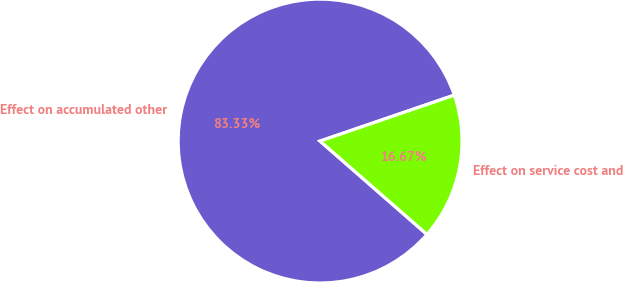Convert chart. <chart><loc_0><loc_0><loc_500><loc_500><pie_chart><fcel>Effect on accumulated other<fcel>Effect on service cost and<nl><fcel>83.33%<fcel>16.67%<nl></chart> 